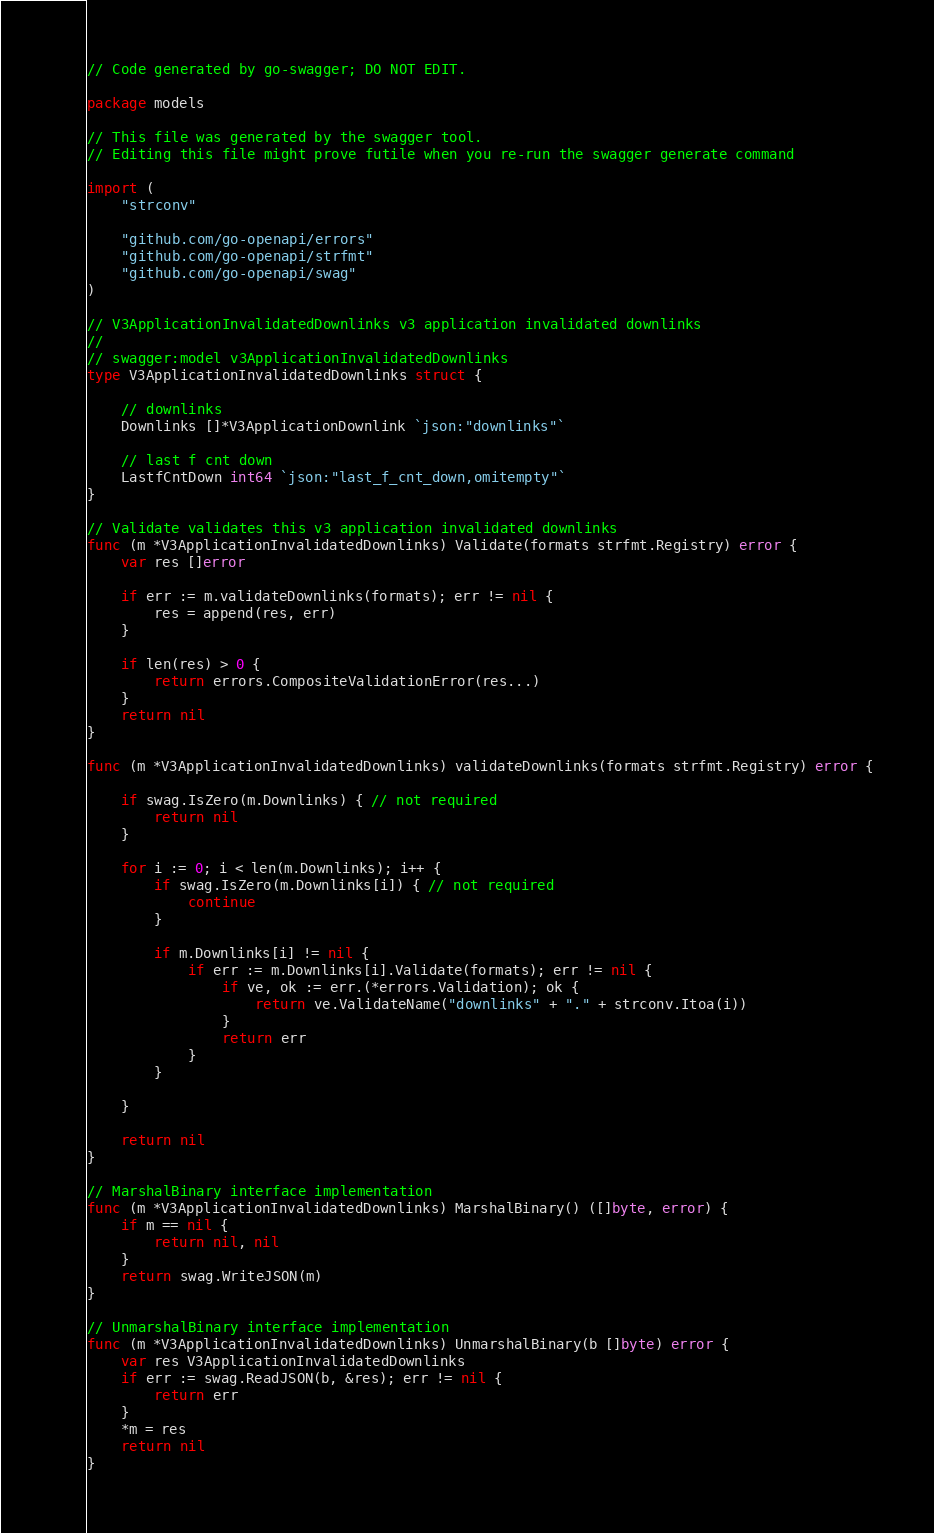Convert code to text. <code><loc_0><loc_0><loc_500><loc_500><_Go_>// Code generated by go-swagger; DO NOT EDIT.

package models

// This file was generated by the swagger tool.
// Editing this file might prove futile when you re-run the swagger generate command

import (
	"strconv"

	"github.com/go-openapi/errors"
	"github.com/go-openapi/strfmt"
	"github.com/go-openapi/swag"
)

// V3ApplicationInvalidatedDownlinks v3 application invalidated downlinks
//
// swagger:model v3ApplicationInvalidatedDownlinks
type V3ApplicationInvalidatedDownlinks struct {

	// downlinks
	Downlinks []*V3ApplicationDownlink `json:"downlinks"`

	// last f cnt down
	LastfCntDown int64 `json:"last_f_cnt_down,omitempty"`
}

// Validate validates this v3 application invalidated downlinks
func (m *V3ApplicationInvalidatedDownlinks) Validate(formats strfmt.Registry) error {
	var res []error

	if err := m.validateDownlinks(formats); err != nil {
		res = append(res, err)
	}

	if len(res) > 0 {
		return errors.CompositeValidationError(res...)
	}
	return nil
}

func (m *V3ApplicationInvalidatedDownlinks) validateDownlinks(formats strfmt.Registry) error {

	if swag.IsZero(m.Downlinks) { // not required
		return nil
	}

	for i := 0; i < len(m.Downlinks); i++ {
		if swag.IsZero(m.Downlinks[i]) { // not required
			continue
		}

		if m.Downlinks[i] != nil {
			if err := m.Downlinks[i].Validate(formats); err != nil {
				if ve, ok := err.(*errors.Validation); ok {
					return ve.ValidateName("downlinks" + "." + strconv.Itoa(i))
				}
				return err
			}
		}

	}

	return nil
}

// MarshalBinary interface implementation
func (m *V3ApplicationInvalidatedDownlinks) MarshalBinary() ([]byte, error) {
	if m == nil {
		return nil, nil
	}
	return swag.WriteJSON(m)
}

// UnmarshalBinary interface implementation
func (m *V3ApplicationInvalidatedDownlinks) UnmarshalBinary(b []byte) error {
	var res V3ApplicationInvalidatedDownlinks
	if err := swag.ReadJSON(b, &res); err != nil {
		return err
	}
	*m = res
	return nil
}
</code> 